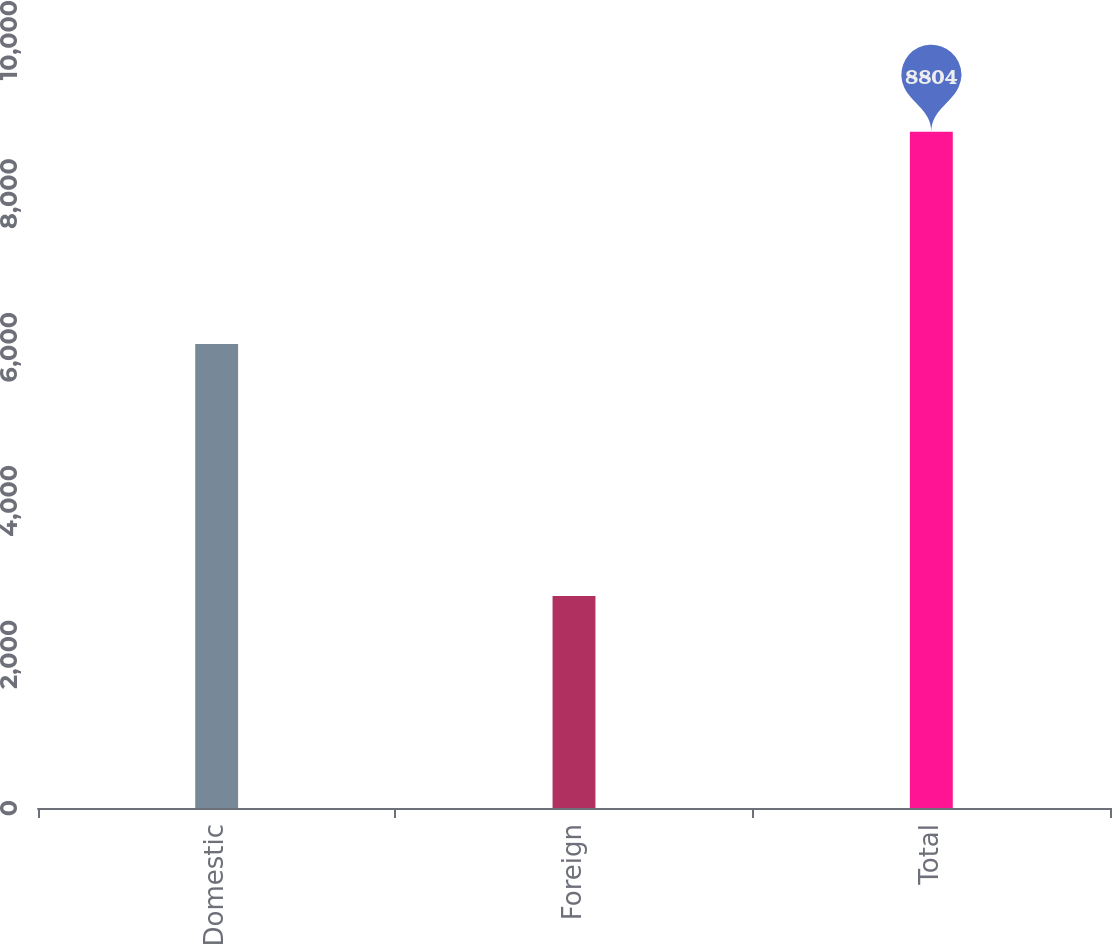<chart> <loc_0><loc_0><loc_500><loc_500><bar_chart><fcel>Domestic<fcel>Foreign<fcel>Total<nl><fcel>6043<fcel>2761<fcel>8804<nl></chart> 